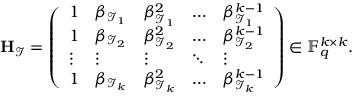<formula> <loc_0><loc_0><loc_500><loc_500>H _ { \mathcal { I } } = \left ( \begin{array} { l l l l l } { 1 } & { \beta _ { \mathcal { I } _ { 1 } } } & { \beta _ { \mathcal { I } _ { 1 } } ^ { 2 } } & { \hdots } & { \beta _ { \mathcal { I } _ { 1 } } ^ { k - 1 } } \\ { 1 } & { \beta _ { \mathcal { I } _ { 2 } } } & { \beta _ { \mathcal { I } _ { 2 } } ^ { 2 } } & { \hdots } & { \beta _ { \mathcal { I } _ { 2 } } ^ { k - 1 } } \\ { \vdots } & { \vdots } & { \vdots } & { \ddots } & { \vdots } \\ { 1 } & { \beta _ { \mathcal { I } _ { k } } } & { \beta _ { \mathcal { I } _ { k } } ^ { 2 } } & { \hdots } & { \beta _ { \mathcal { I } _ { k } } ^ { k - 1 } } \end{array} \right ) \in \mathbb { F } _ { q } ^ { k \times k } .</formula> 